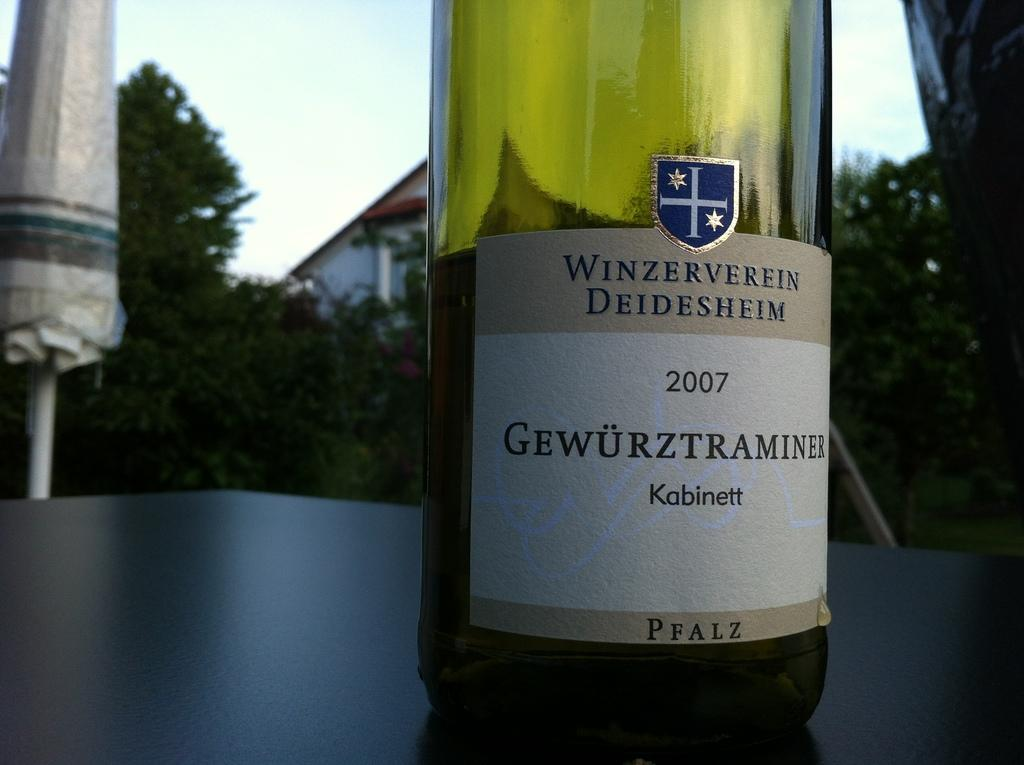<image>
Share a concise interpretation of the image provided. a bottle of Winzerverein Deidesheim Kabinett 2007 wine 